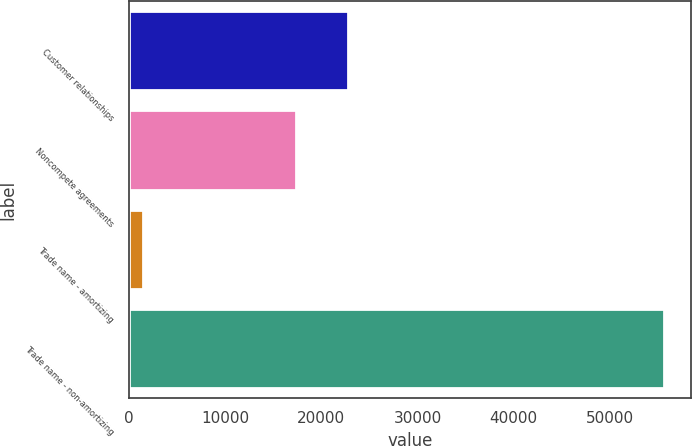Convert chart. <chart><loc_0><loc_0><loc_500><loc_500><bar_chart><fcel>Customer relationships<fcel>Noncompete agreements<fcel>Trade name - amortizing<fcel>Trade name - non-amortizing<nl><fcel>22782.7<fcel>17364<fcel>1450<fcel>55637<nl></chart> 